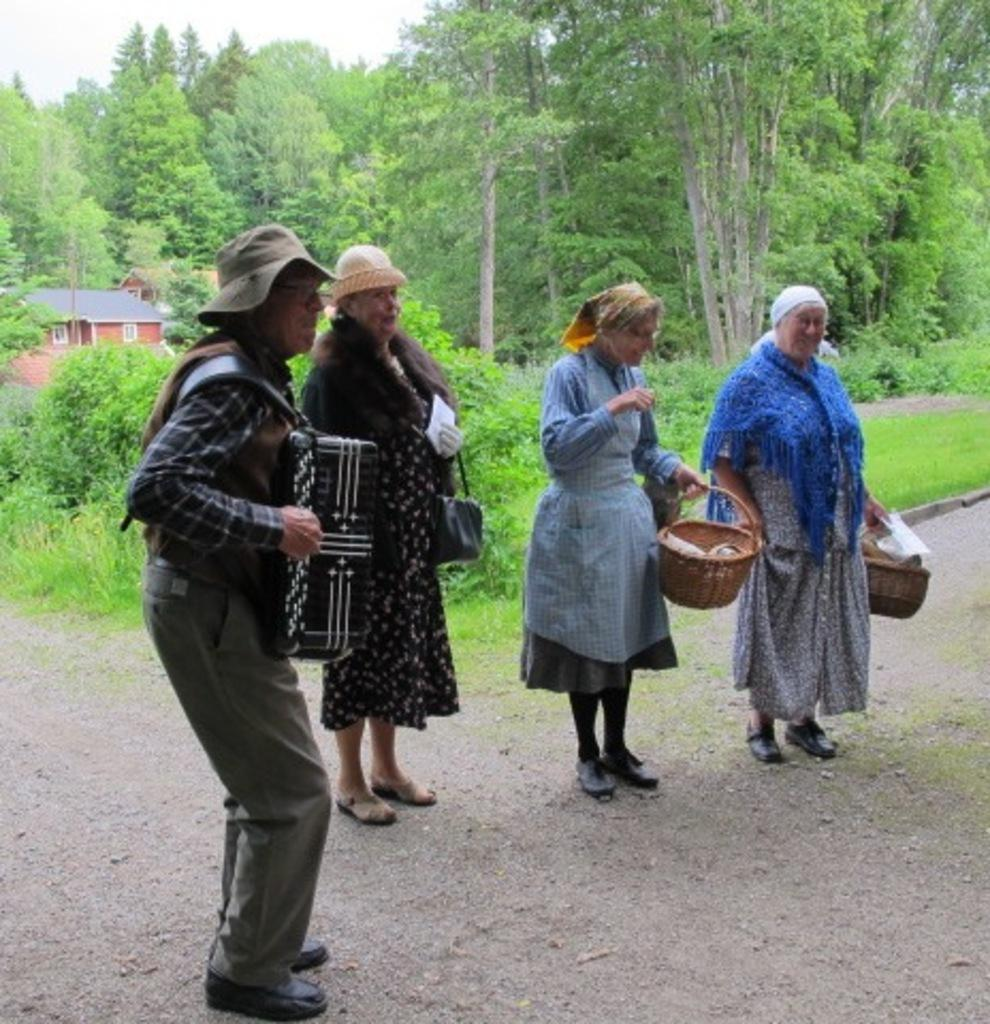How many people are in the image? There is a group of people in the image. Where are the people located in the image? The people are standing on the road. What can be seen in the background of the image? There is a house, trees, and the sky visible in the background of the image. What type of rose is being held by the squirrel in the image? There is no rose or squirrel present in the image. Are the people in the image friends or acquaintances? The image does not provide information about the relationships between the people, so it cannot be determined if they are friends or acquaintances. 